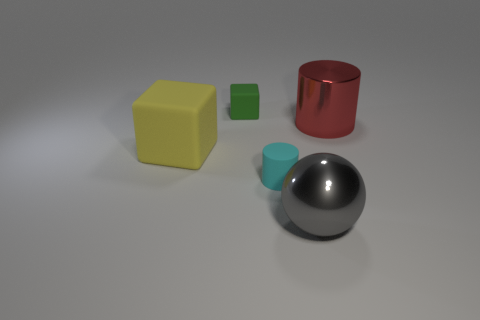There is a green rubber object; is its size the same as the shiny cylinder behind the large gray ball?
Offer a very short reply. No. What is the material of the object behind the big red metallic cylinder?
Ensure brevity in your answer.  Rubber. What number of objects are right of the ball and left of the small cyan cylinder?
Offer a very short reply. 0. What material is the cylinder that is the same size as the yellow block?
Provide a short and direct response. Metal. There is a rubber block in front of the green thing; does it have the same size as the matte block behind the red cylinder?
Provide a succinct answer. No. There is a tiny cyan cylinder; are there any objects behind it?
Give a very brief answer. Yes. What is the color of the cylinder that is in front of the big thing that is behind the large yellow block?
Offer a very short reply. Cyan. Are there fewer cyan metallic spheres than big gray shiny objects?
Give a very brief answer. Yes. What number of tiny objects have the same shape as the large rubber object?
Keep it short and to the point. 1. The rubber cube that is the same size as the cyan rubber cylinder is what color?
Provide a succinct answer. Green. 